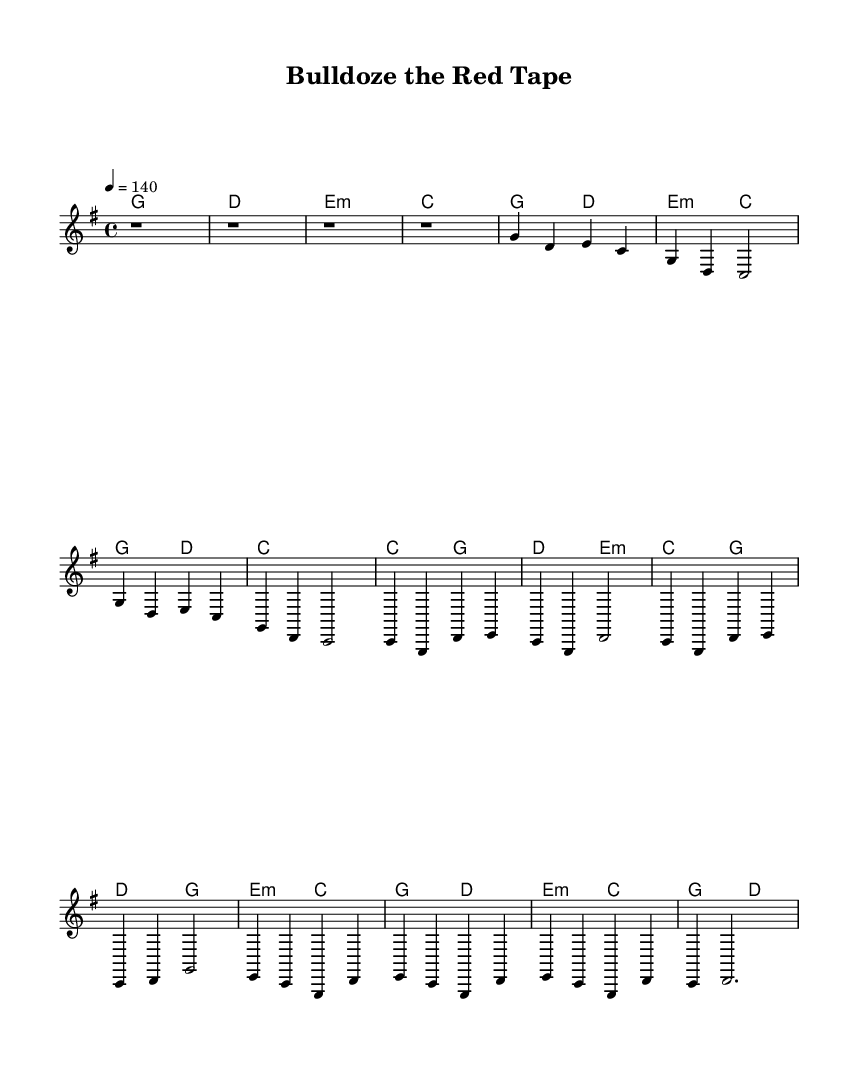What is the key signature of this music? The key signature is G major, indicated at the beginning of the staff with one sharp (F#).
Answer: G major What is the time signature of the piece? The time signature is 4/4, shown at the beginning of the score. This means there are four beats in each measure.
Answer: 4/4 What is the tempo marking for this music? The tempo marking indicates a speed of quarter note equals 140 beats per minute, specified at the top of the score with "4 = 140."
Answer: 140 How many measures are in the verse? The verse consists of two lines, each containing four measures, totaling to eight measures.
Answer: 8 Which section follows the bridge in the song structure? After the bridge, the song repeats the chorus, indicated by the structure of the lyrics and music sections as laid out in the score.
Answer: Chorus What is the main theme of the lyrics? The lyrics revolve around overcoming bureaucratic hurdles and fighting through legal challenges in development projects.
Answer: Overcoming obstacles What musical elements are typical for Country Rock found in this piece? Typical elements in Country Rock include a strong backbeat, catchy melodies, and themes associated with everyday life and challenges, all of which are present in this music.
Answer: Strong backbeat and catchy melodies 